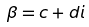<formula> <loc_0><loc_0><loc_500><loc_500>\beta = c + d i</formula> 